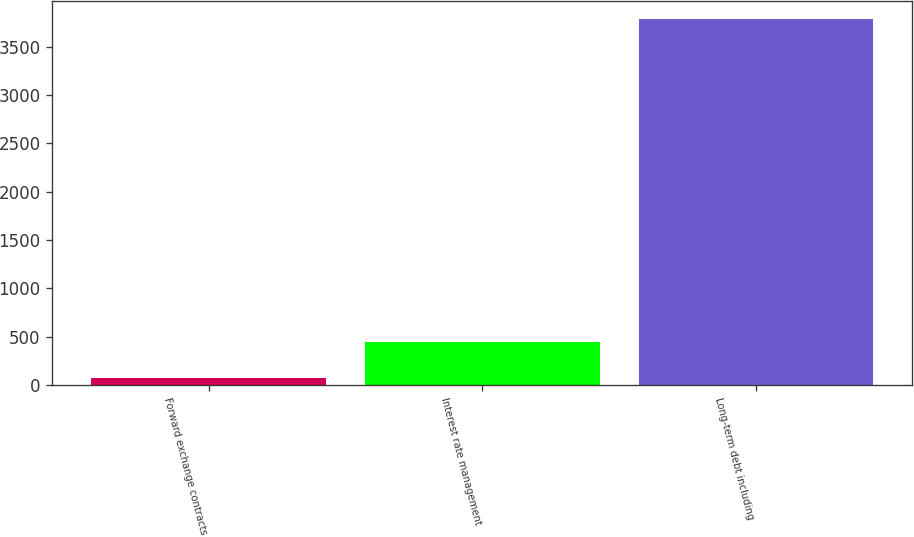Convert chart. <chart><loc_0><loc_0><loc_500><loc_500><bar_chart><fcel>Forward exchange contracts<fcel>Interest rate management<fcel>Long-term debt including<nl><fcel>68.8<fcel>440.74<fcel>3788.2<nl></chart> 